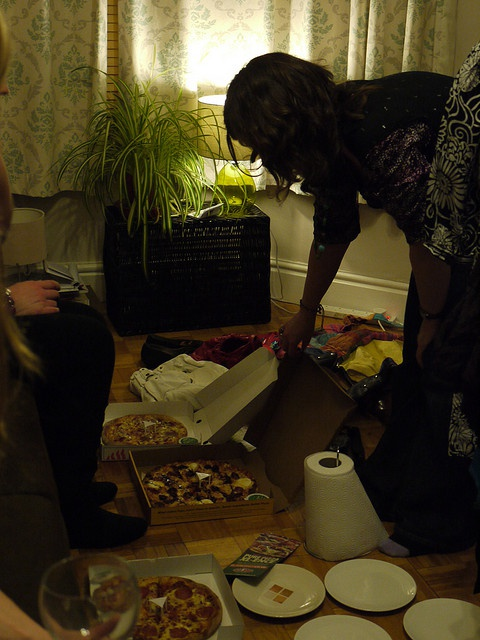Describe the objects in this image and their specific colors. I can see people in olive, black, and gray tones, potted plant in olive and black tones, people in olive, black, and maroon tones, couch in black, maroon, and olive tones, and couch in olive and black tones in this image. 